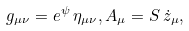<formula> <loc_0><loc_0><loc_500><loc_500>g _ { \mu \nu } = e ^ { \psi } \, \eta _ { \mu \nu } , A _ { \mu } = S \, \dot { z } _ { \mu } ,</formula> 